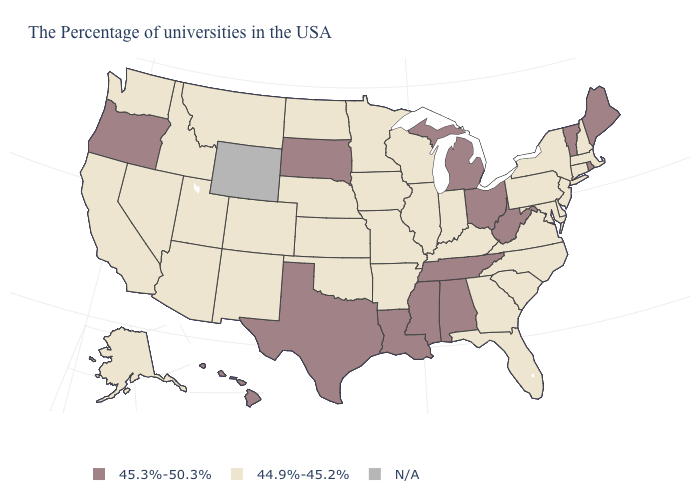Among the states that border Michigan , does Ohio have the lowest value?
Concise answer only. No. How many symbols are there in the legend?
Write a very short answer. 3. Name the states that have a value in the range N/A?
Keep it brief. Wyoming. What is the highest value in the USA?
Be succinct. 45.3%-50.3%. What is the highest value in states that border New Jersey?
Be succinct. 44.9%-45.2%. What is the highest value in states that border Kentucky?
Answer briefly. 45.3%-50.3%. Which states have the highest value in the USA?
Short answer required. Maine, Rhode Island, Vermont, West Virginia, Ohio, Michigan, Alabama, Tennessee, Mississippi, Louisiana, Texas, South Dakota, Oregon, Hawaii. Which states have the lowest value in the West?
Be succinct. Colorado, New Mexico, Utah, Montana, Arizona, Idaho, Nevada, California, Washington, Alaska. Name the states that have a value in the range N/A?
Answer briefly. Wyoming. Name the states that have a value in the range N/A?
Keep it brief. Wyoming. What is the value of Tennessee?
Be succinct. 45.3%-50.3%. Does Rhode Island have the highest value in the Northeast?
Quick response, please. Yes. Name the states that have a value in the range N/A?
Give a very brief answer. Wyoming. What is the value of Ohio?
Concise answer only. 45.3%-50.3%. 